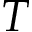Convert formula to latex. <formula><loc_0><loc_0><loc_500><loc_500>T</formula> 